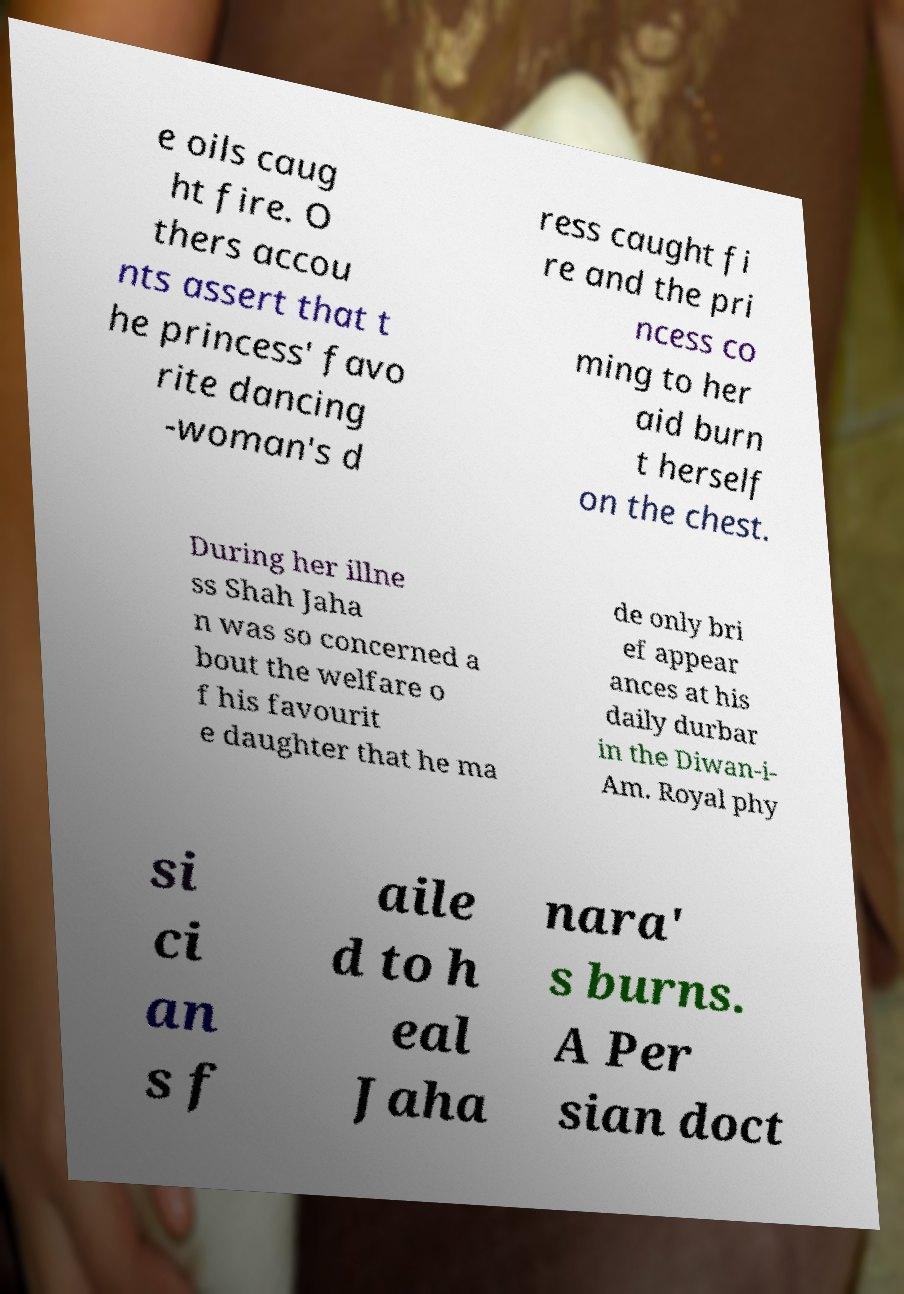Please identify and transcribe the text found in this image. e oils caug ht fire. O thers accou nts assert that t he princess' favo rite dancing -woman's d ress caught fi re and the pri ncess co ming to her aid burn t herself on the chest. During her illne ss Shah Jaha n was so concerned a bout the welfare o f his favourit e daughter that he ma de only bri ef appear ances at his daily durbar in the Diwan-i- Am. Royal phy si ci an s f aile d to h eal Jaha nara' s burns. A Per sian doct 